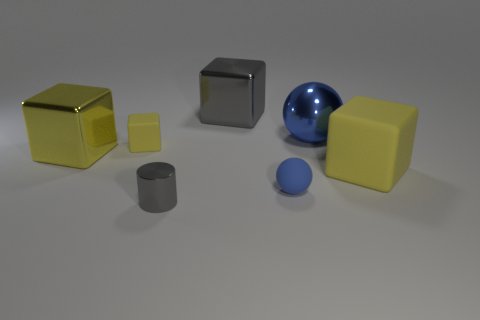Subtract all yellow cubes. How many were subtracted if there are1yellow cubes left? 2 Subtract all cyan cylinders. How many yellow cubes are left? 3 Subtract all gray cubes. How many cubes are left? 3 Subtract 1 blocks. How many blocks are left? 3 Subtract all purple cubes. Subtract all brown spheres. How many cubes are left? 4 Add 1 big gray metallic objects. How many objects exist? 8 Subtract all cylinders. How many objects are left? 6 Subtract 0 blue cubes. How many objects are left? 7 Subtract all blue shiny things. Subtract all yellow blocks. How many objects are left? 3 Add 3 large things. How many large things are left? 7 